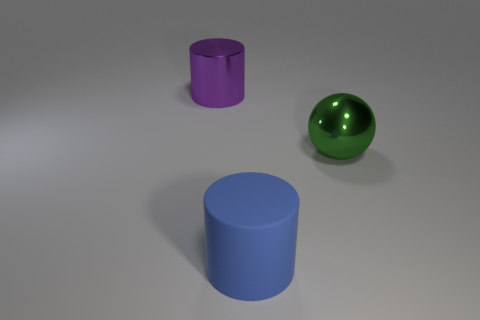Is there a big sphere of the same color as the matte object?
Ensure brevity in your answer.  No. How many other objects are there of the same shape as the blue rubber thing?
Provide a succinct answer. 1. The shiny thing on the right side of the metallic cylinder has what shape?
Your response must be concise. Sphere. There is a large blue matte thing; is it the same shape as the object behind the green metallic object?
Your response must be concise. Yes. There is a object that is in front of the purple shiny thing and left of the green metallic ball; how big is it?
Offer a very short reply. Large. What color is the big object that is both behind the blue rubber thing and left of the sphere?
Keep it short and to the point. Purple. Is there any other thing that has the same material as the sphere?
Your answer should be compact. Yes. Is the number of large purple metallic things behind the purple thing less than the number of big green spheres that are left of the large blue matte cylinder?
Your answer should be very brief. No. Is there anything else that is the same color as the large metal sphere?
Make the answer very short. No. The large rubber thing is what shape?
Ensure brevity in your answer.  Cylinder. 